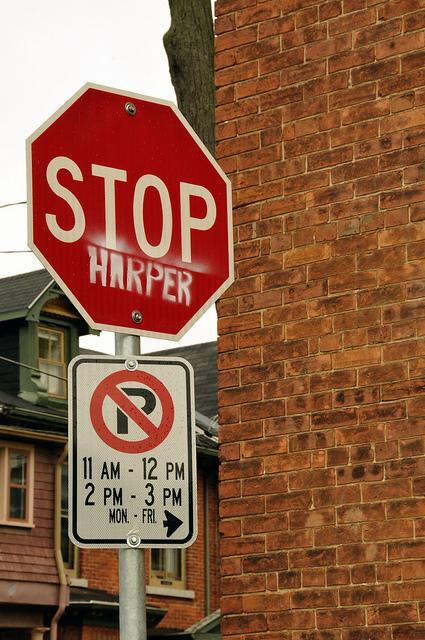What is the wall made of behind the sign?
Write a very short answer. Brick. Is the sign hanging on the wall?
Short answer required. No. Are both signs round?
Give a very brief answer. No. What is written on the sign?
Keep it brief. Stop harper. What day of the week is the sign not applicable?
Be succinct. Saturday and sunday. What share are the two signs?
Quick response, please. Octagon and rectangle. What is the wall in the background made of?
Give a very brief answer. Brick. What is the color of the stop sign?
Keep it brief. Red. 